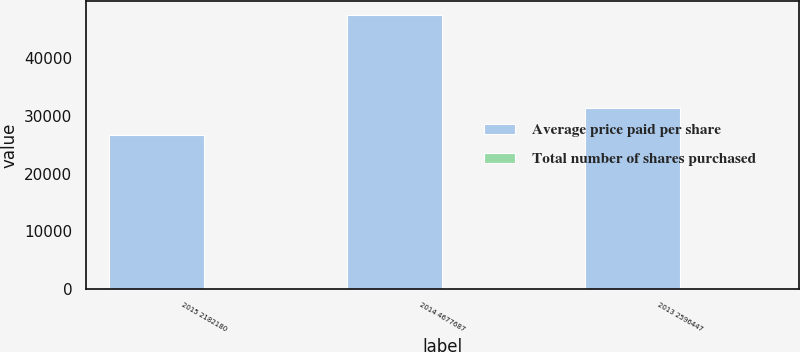Convert chart. <chart><loc_0><loc_0><loc_500><loc_500><stacked_bar_chart><ecel><fcel>2015 2182180<fcel>2014 4677687<fcel>2013 2596447<nl><fcel>Average price paid per share<fcel>26751<fcel>47545.9<fcel>31349.5<nl><fcel>Total number of shares purchased<fcel>81.57<fcel>98.38<fcel>82.82<nl></chart> 